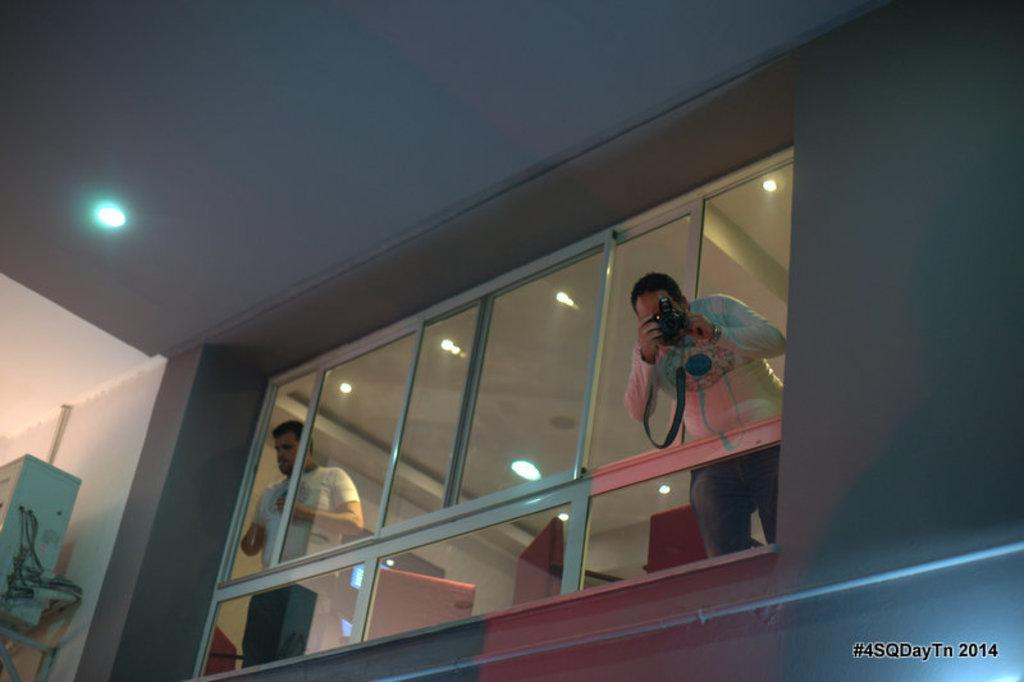How many people are in the image? There are two persons in the image. What is one person doing with their hands? One person is holding a camera with their hands. What can be seen in the background of the image? There is a wall in the image. What type of objects are present in the image? There are lights, glasses, and an object in the image. What is above the people in the image? There is a ceiling in the image. Can you tell me how many eggs are on the sidewalk in the image? There are no eggs or sidewalks present in the image. What color are the toes of the person holding the camera? There is no information about the person's toes in the image. 